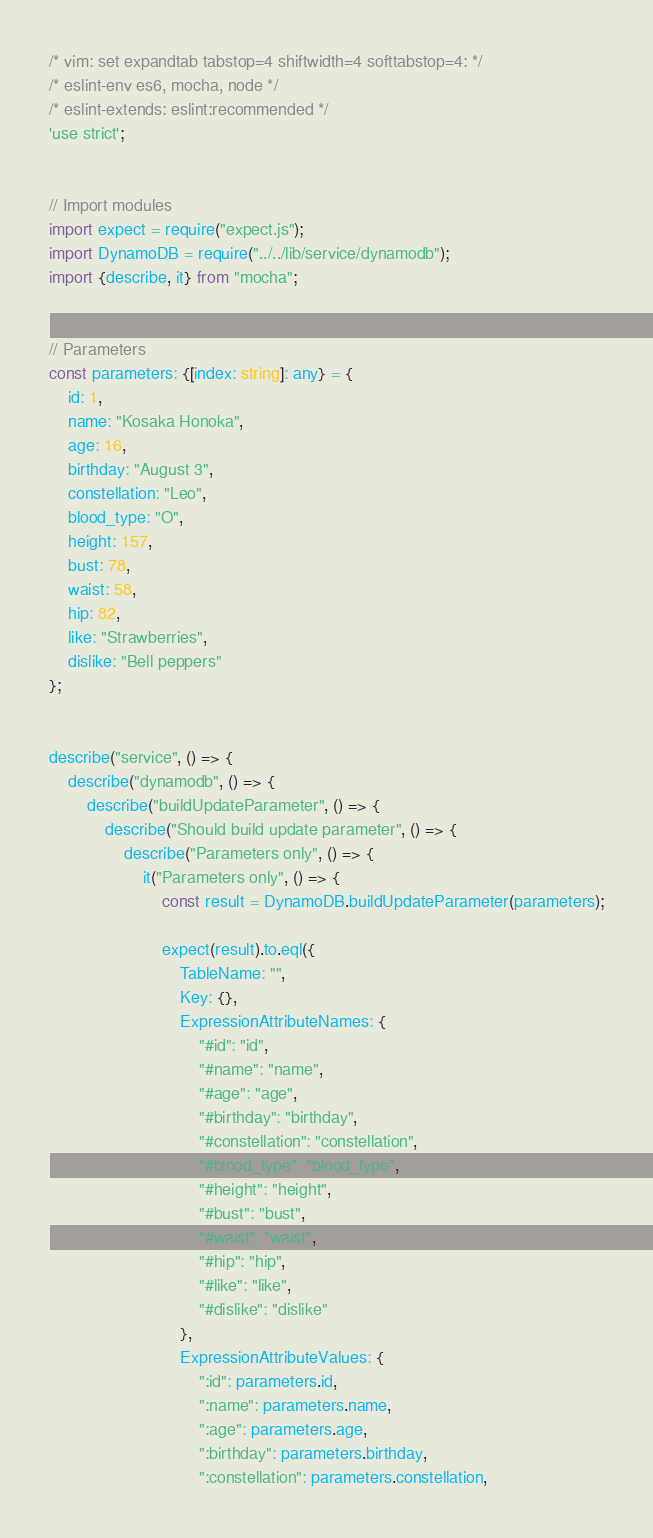<code> <loc_0><loc_0><loc_500><loc_500><_TypeScript_>/* vim: set expandtab tabstop=4 shiftwidth=4 softtabstop=4: */
/* eslint-env es6, mocha, node */
/* eslint-extends: eslint:recommended */
'use strict';


// Import modules
import expect = require("expect.js");
import DynamoDB = require("../../lib/service/dynamodb");
import {describe, it} from "mocha";


// Parameters
const parameters: {[index: string]: any} = {
    id: 1,
    name: "Kosaka Honoka",
    age: 16,
    birthday: "August 3",
    constellation: "Leo",
    blood_type: "O",
    height: 157,
    bust: 78,
    waist: 58,
    hip: 82,
    like: "Strawberries",
    dislike: "Bell peppers"
};


describe("service", () => {
    describe("dynamodb", () => {
        describe("buildUpdateParameter", () => {
            describe("Should build update parameter", () => {
                describe("Parameters only", () => {
                    it("Parameters only", () => {
                        const result = DynamoDB.buildUpdateParameter(parameters);

                        expect(result).to.eql({
                            TableName: "",
                            Key: {},
                            ExpressionAttributeNames: {
                                "#id": "id",
                                "#name": "name",
                                "#age": "age",
                                "#birthday": "birthday",
                                "#constellation": "constellation",
                                "#blood_type": "blood_type",
                                "#height": "height",
                                "#bust": "bust",
                                "#waist": "waist",
                                "#hip": "hip",
                                "#like": "like",
                                "#dislike": "dislike"
                            },
                            ExpressionAttributeValues: {
                                ":id": parameters.id,
                                ":name": parameters.name,
                                ":age": parameters.age,
                                ":birthday": parameters.birthday,
                                ":constellation": parameters.constellation,</code> 